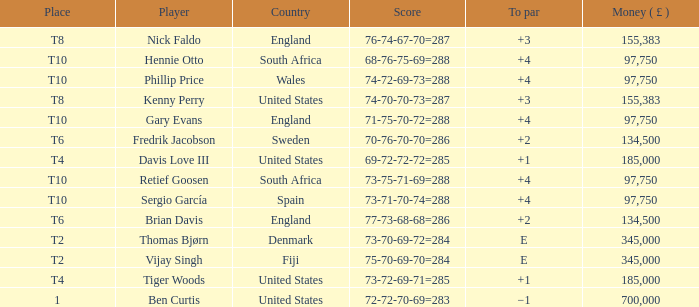What is the Place of Davis Love III with a To Par of +1? T4. 